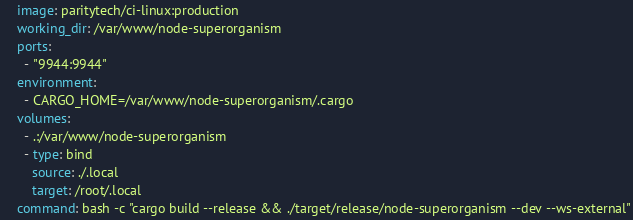Convert code to text. <code><loc_0><loc_0><loc_500><loc_500><_YAML_>    image: paritytech/ci-linux:production
    working_dir: /var/www/node-superorganism
    ports:
      - "9944:9944"
    environment:
      - CARGO_HOME=/var/www/node-superorganism/.cargo
    volumes:
      - .:/var/www/node-superorganism
      - type: bind
        source: ./.local
        target: /root/.local
    command: bash -c "cargo build --release && ./target/release/node-superorganism --dev --ws-external"
</code> 